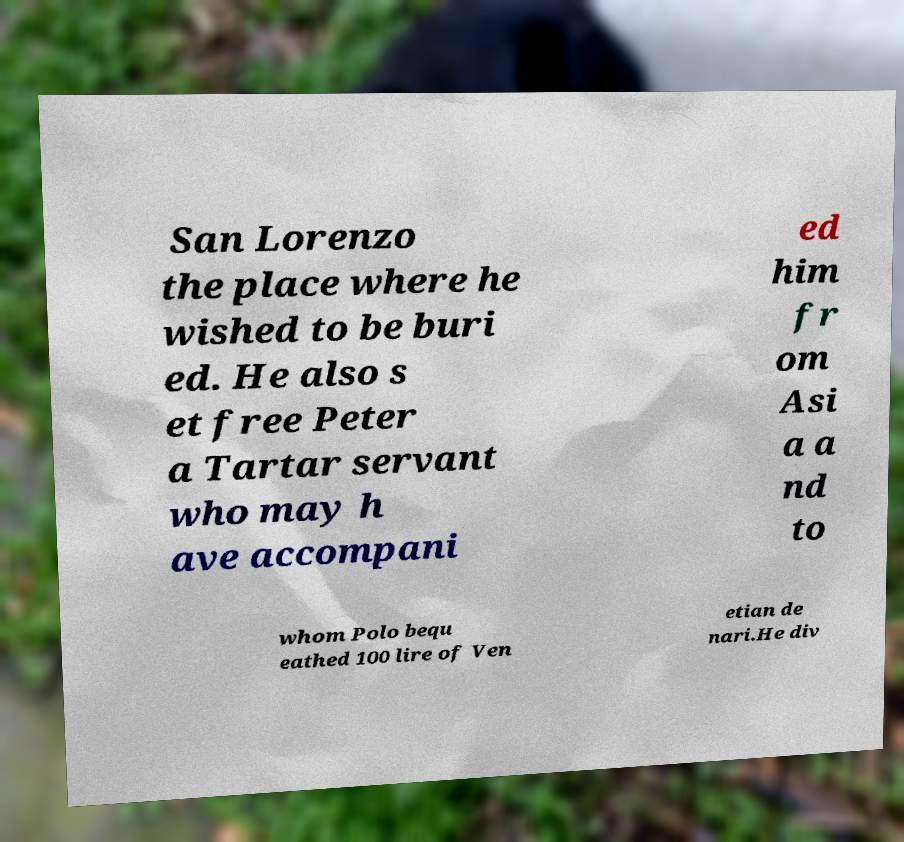For documentation purposes, I need the text within this image transcribed. Could you provide that? San Lorenzo the place where he wished to be buri ed. He also s et free Peter a Tartar servant who may h ave accompani ed him fr om Asi a a nd to whom Polo bequ eathed 100 lire of Ven etian de nari.He div 